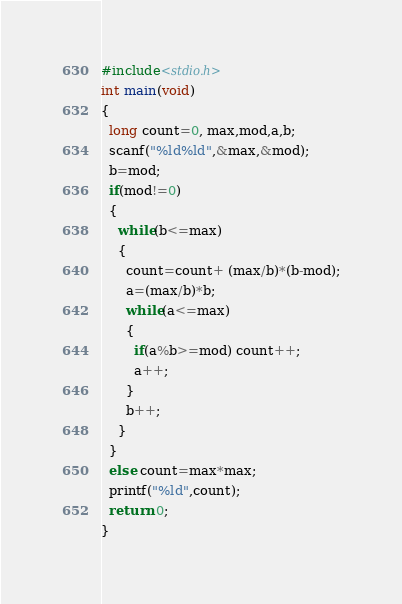Convert code to text. <code><loc_0><loc_0><loc_500><loc_500><_C_>#include<stdio.h>
int main(void)
{
  long count=0, max,mod,a,b;
  scanf("%ld%ld",&max,&mod);
  b=mod;
  if(mod!=0)
  {
    while(b<=max)
    {
      count=count+ (max/b)*(b-mod);
      a=(max/b)*b;
      while(a<=max)
      {
        if(a%b>=mod) count++;
        a++;
      }
      b++;
    }
  }
  else count=max*max;
  printf("%ld",count);
  return 0;
}</code> 